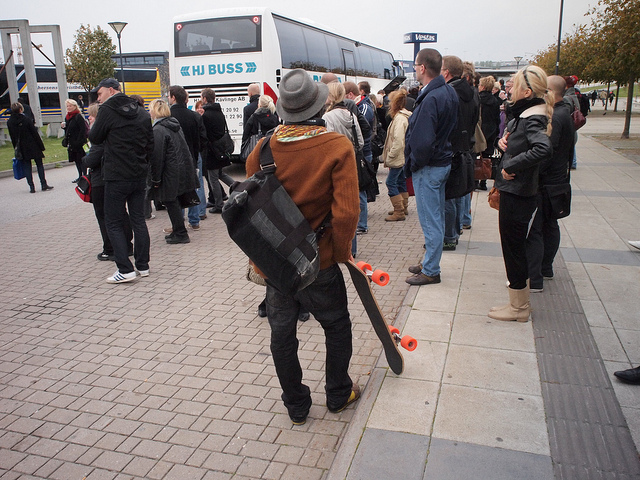Identify the text contained in this image. HJ BUSS 